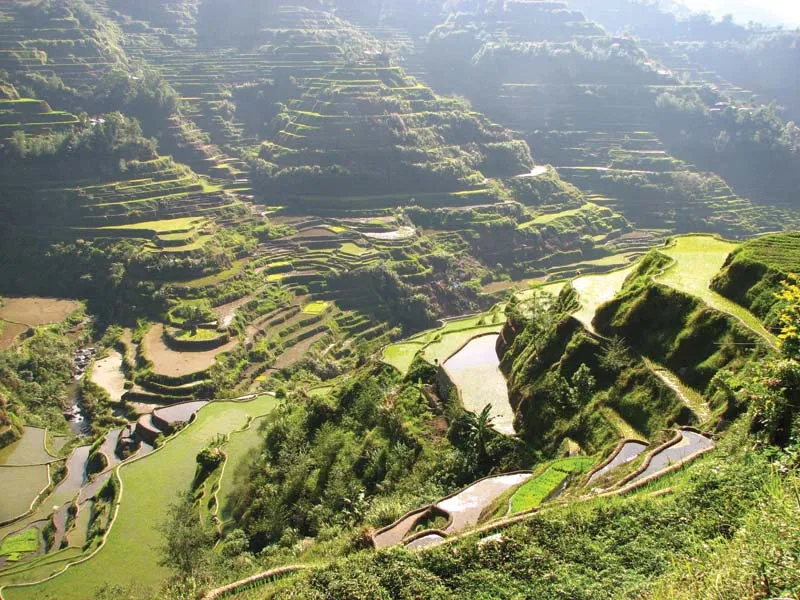Imagine the terraces come to life. How would they tell their story? If the Banaue Rice Terraces could speak, they would recount a tale of human ingenuity and perseverance, stretching across two millennia. They would tell of the Ifugao ancestors who, with bare hands and simple tools, carved out steps on the rugged mountainsides, transforming the land into fertile fields. Each terrace would share stories of generations laboring dawn till dusk, planting, tending, and harvesting rice, always respectful of the delicate balance of nature. They would whisper about the intricate knowledge of water management, the rituals performed for bountiful harvests, and the festivals that celebrated the cycles of life. The terraces would speak proudly of their recognition as a UNESCO World Heritage Site, a nod to their cultural and historical significance, while also expressing concerns about the challenges posed by modernity and climate change. They would ultimately portray themselves as living symbols of resilience and the harmonious relationship between humans and the environment. What might a day in the life of a farmer working these terraces look like? A typical day for a farmer in the Banaue Rice Terraces begins before sunrise. As dawn breaks, the farmer heads to the terraces, often accompanied by family members. They start by checking the water levels and ensuring the careful flow of irrigation channels. The morning might be spent planting rice seedlings or tending to the growing crops, pulling out weeds and maintaining the stone walls of the terraces. After a simple meal, usually consisting of rice and vegetables, the farmer continues work, perhaps fixing any damage to the terraces caused by erosion or heavy rains. In the late afternoon, they may engage in community activities, participating in cooperative efforts to maintain the shared irrigation system. As the sun sets, the farmer returns home, often weary but content, knowing that their labor contributes to both their family's sustenance and the preservation of a millennia-old tradition. The evening might be spent in the company of family, sharing stories or engaging in cultural practices that keep the Ifugao heritage alive.  Could these terraces exist on another planet? What would that look like? Imagine a distant world, with vast mountain ranges bathed in the light of twin suns. On this alien landscape, advanced terraforming technologies were employed by a civilization of farmers who adapted the concept of terracing. Each step is not for rice, but for exotic crops that thrive on this planet's unique soil and climate. Neon-colored plants shimmer in the rays, growing in perfect harmony with the artificial irrigation rivers flowing with bioluminescent water, sourced from underground reservoirs. The terraces, composed of a crystalline mineral unknown on Earth, form intricate patterns visible from space. As dusk falls, the entire terraced landscape glows softly, creating a surreal and otherworldly nightscape, a testament to the universal principles of agriculture practiced across galaxies.  How does climate change threaten these terraces? Climate change poses several threats to the Banaue Rice Terraces. Changes in rainfall patterns can lead to prolonged droughts or intense storms, both of which threaten the delicate balance required for rice cultivation. Erosion and landslides become more frequent with severe weather, potentially destroying parts of the terraces. Additionally, rising temperatures can affect the growth cycle of rice, leading to reduced yields. Ultimately, the changing climate undermines the sustainability of the traditional farming practices that have maintained these terraces for generations, endangering both the local economy and cultural heritage.  Describe a realistic scenario where international cooperation helps preserve these terraces. In a bid to preserve the Banaue Rice Terraces, countries around the world come together to support the Philippines in implementing sustainable agricultural practices. They provide funding and technological assistance to build advanced irrigation systems that conserve water and prevent erosion. Agricultural scientists from different nations collaborate with local farmers to develop and introduce drought-resistant rice varieties. Furthermore, international organizations work to promote eco-tourism, ensuring that tourism benefits local communities while minimizing environmental impacts. This global effort not only helps preserve the terraces but also empowers the local Ifugao population to continue their traditional way of life in harmony with modern sustainable practices.  What would a casual conversation with a local living near the terraces sound like? Visitor: 'Hi there! The terraces are absolutely breathtaking. Do you work on them?'
Local: 'Oh, hi! Yes, my family has been farming these terraces for generations. It's hard work, but it's also very rewarding.'
Visitor: 'I can imagine. What’s it like living here?'
Local: 'It's peaceful and beautiful. We rely on the land for food and our traditions. It's a tight-knit community and we all help each other out.'
Visitor: 'That sounds wonderful. How do you keep the terraces so well maintained?'
Local: 'It's a lot of daily work. We make sure the water flows properly and repair any damage quickly. It’s a community effort, and everyone plays a part in looking after them.' 